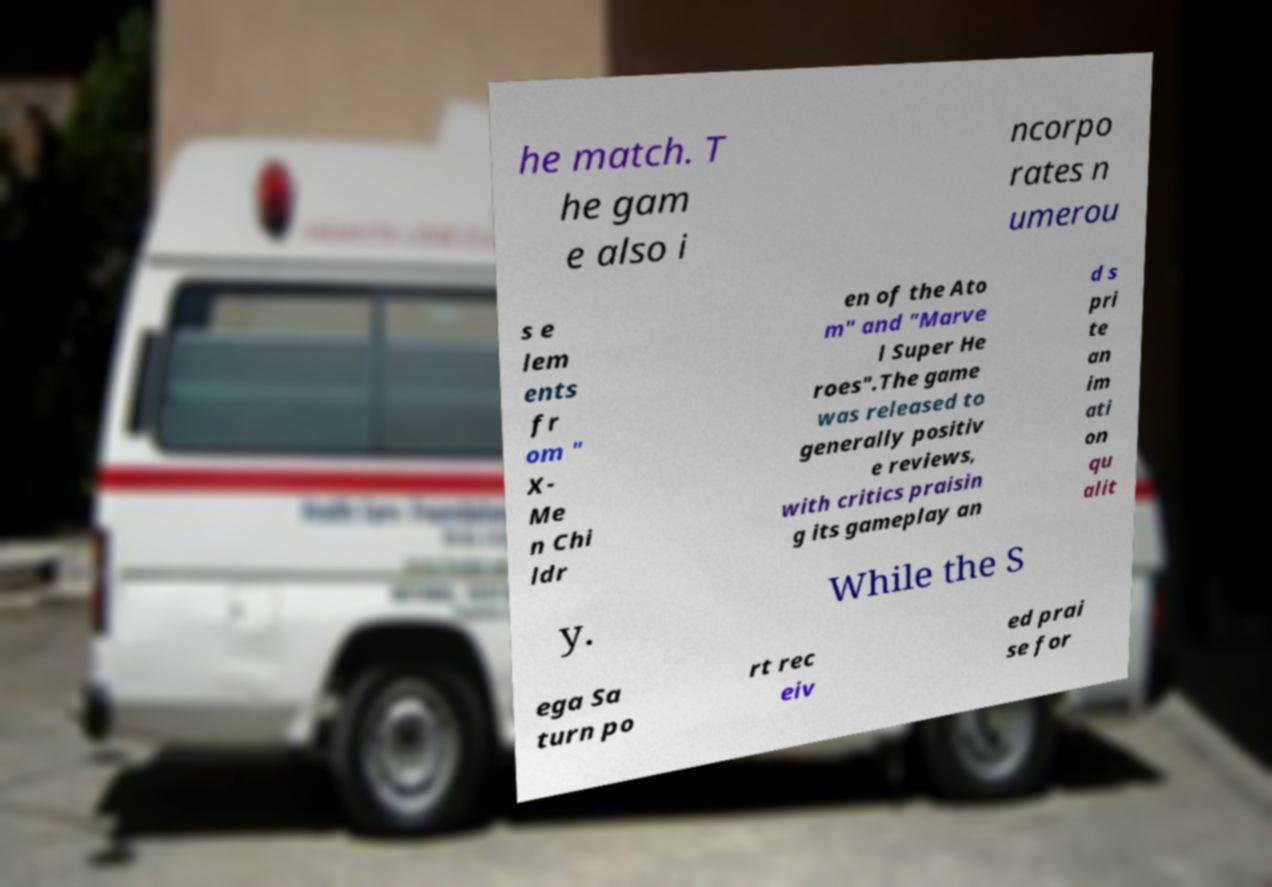Could you extract and type out the text from this image? he match. T he gam e also i ncorpo rates n umerou s e lem ents fr om " X- Me n Chi ldr en of the Ato m" and "Marve l Super He roes".The game was released to generally positiv e reviews, with critics praisin g its gameplay an d s pri te an im ati on qu alit y. While the S ega Sa turn po rt rec eiv ed prai se for 